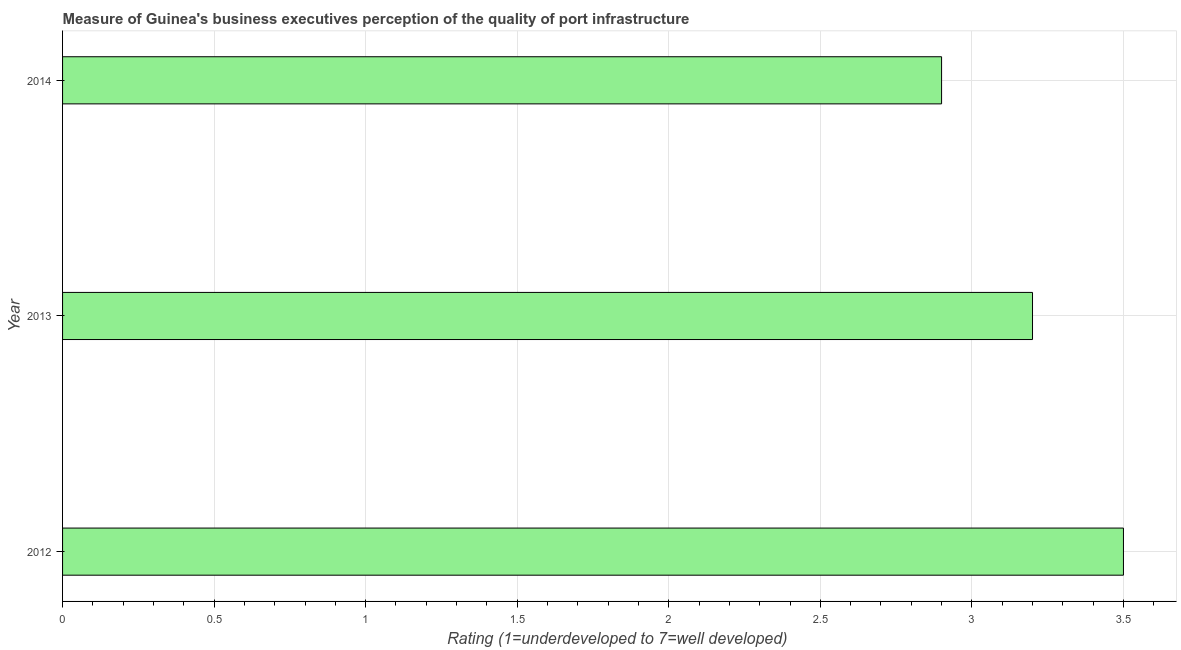Does the graph contain grids?
Your answer should be compact. Yes. What is the title of the graph?
Ensure brevity in your answer.  Measure of Guinea's business executives perception of the quality of port infrastructure. What is the label or title of the X-axis?
Your response must be concise. Rating (1=underdeveloped to 7=well developed) . What is the rating measuring quality of port infrastructure in 2014?
Ensure brevity in your answer.  2.9. In which year was the rating measuring quality of port infrastructure maximum?
Provide a short and direct response. 2012. In which year was the rating measuring quality of port infrastructure minimum?
Your response must be concise. 2014. What is the difference between the rating measuring quality of port infrastructure in 2012 and 2013?
Your answer should be compact. 0.3. What is the average rating measuring quality of port infrastructure per year?
Provide a short and direct response. 3.2. What is the median rating measuring quality of port infrastructure?
Give a very brief answer. 3.2. Do a majority of the years between 2013 and 2012 (inclusive) have rating measuring quality of port infrastructure greater than 2.2 ?
Your response must be concise. No. What is the ratio of the rating measuring quality of port infrastructure in 2012 to that in 2014?
Offer a very short reply. 1.21. Is the rating measuring quality of port infrastructure in 2012 less than that in 2014?
Offer a terse response. No. Is the difference between the rating measuring quality of port infrastructure in 2012 and 2013 greater than the difference between any two years?
Your response must be concise. No. What is the difference between the highest and the second highest rating measuring quality of port infrastructure?
Provide a short and direct response. 0.3. Is the sum of the rating measuring quality of port infrastructure in 2012 and 2014 greater than the maximum rating measuring quality of port infrastructure across all years?
Offer a very short reply. Yes. How many bars are there?
Your answer should be compact. 3. Are all the bars in the graph horizontal?
Ensure brevity in your answer.  Yes. Are the values on the major ticks of X-axis written in scientific E-notation?
Your answer should be compact. No. What is the difference between the Rating (1=underdeveloped to 7=well developed)  in 2012 and 2014?
Keep it short and to the point. 0.6. What is the ratio of the Rating (1=underdeveloped to 7=well developed)  in 2012 to that in 2013?
Your answer should be compact. 1.09. What is the ratio of the Rating (1=underdeveloped to 7=well developed)  in 2012 to that in 2014?
Your response must be concise. 1.21. What is the ratio of the Rating (1=underdeveloped to 7=well developed)  in 2013 to that in 2014?
Offer a terse response. 1.1. 